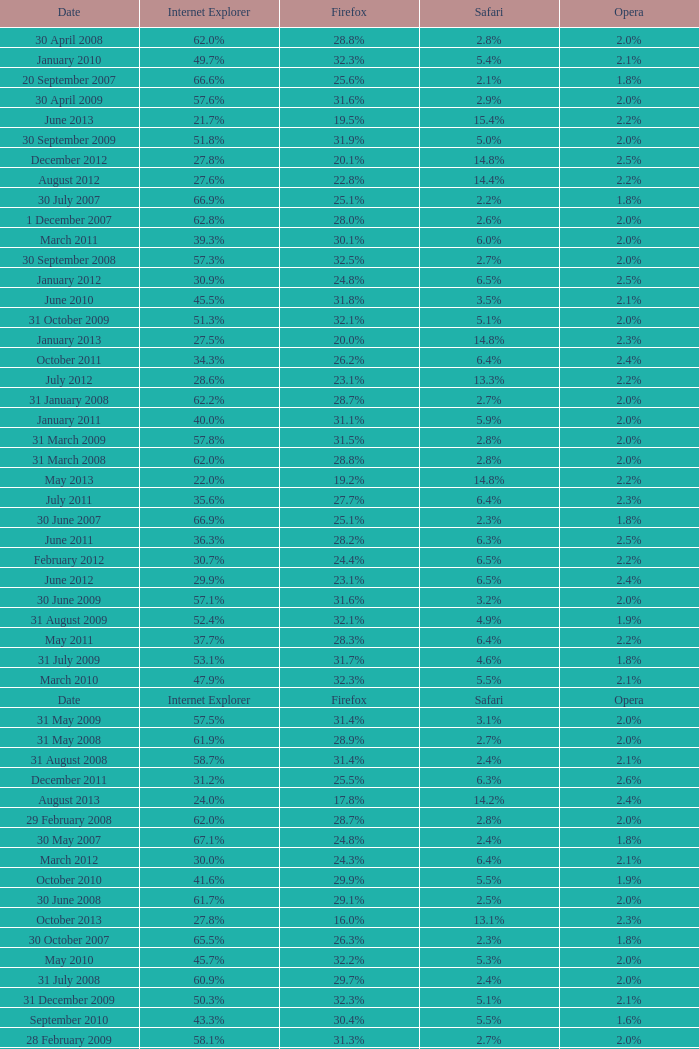What is the safari value with a 28.0% internet explorer? 14.3%. 